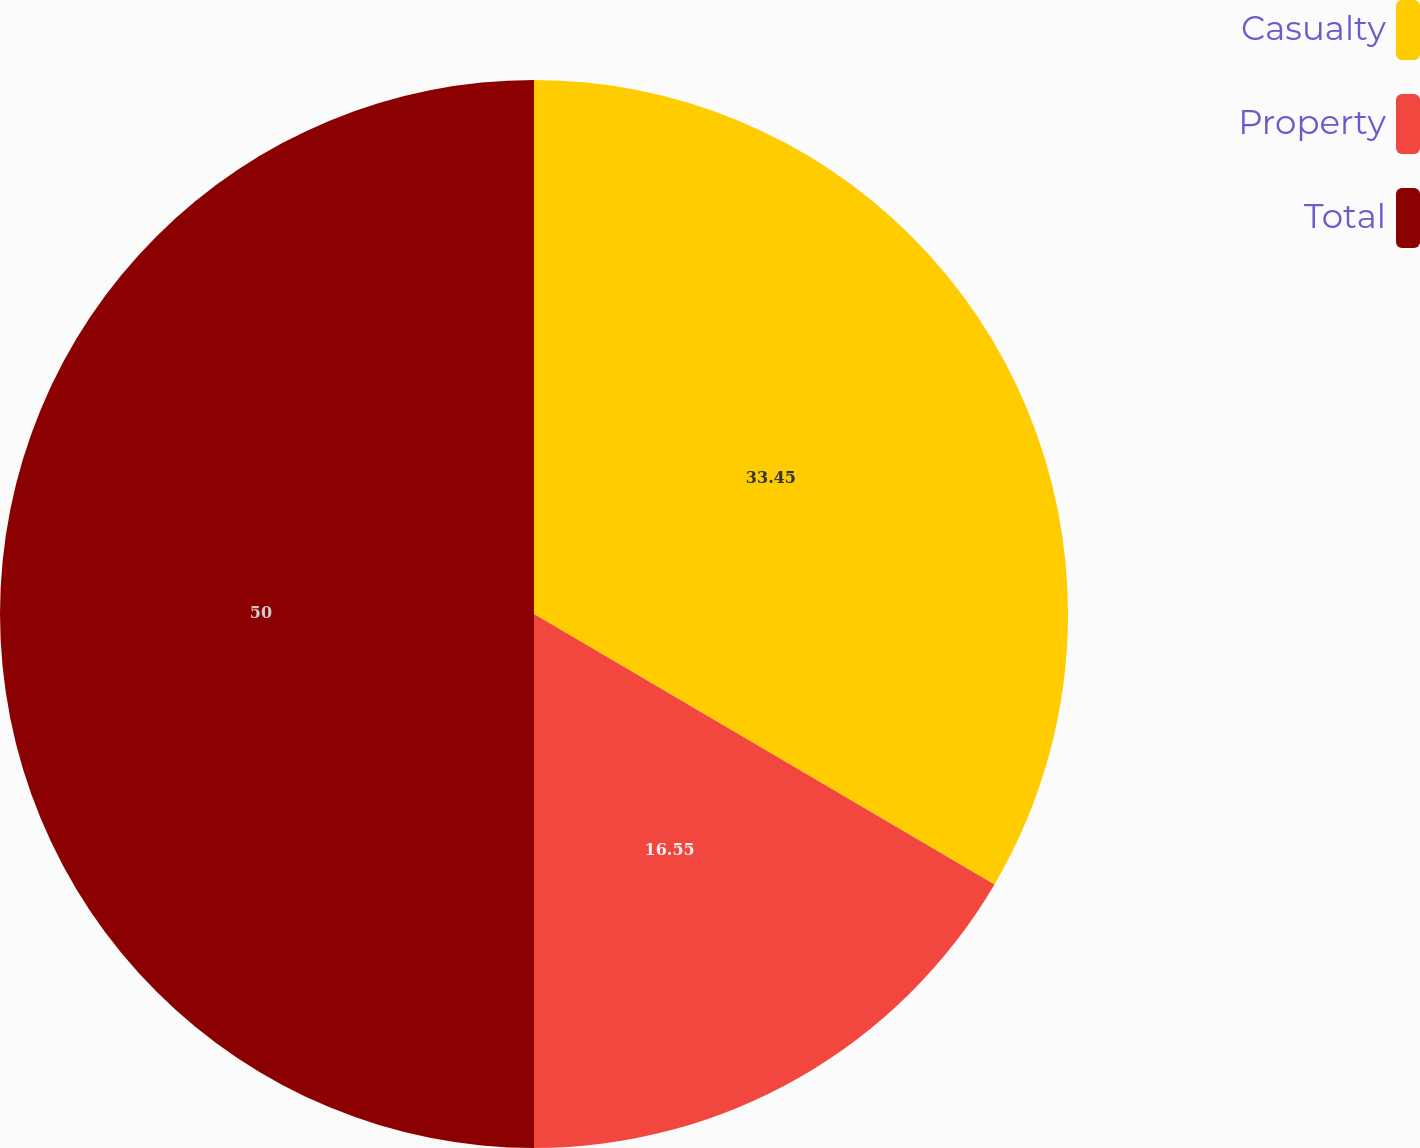<chart> <loc_0><loc_0><loc_500><loc_500><pie_chart><fcel>Casualty<fcel>Property<fcel>Total<nl><fcel>33.45%<fcel>16.55%<fcel>50.0%<nl></chart> 